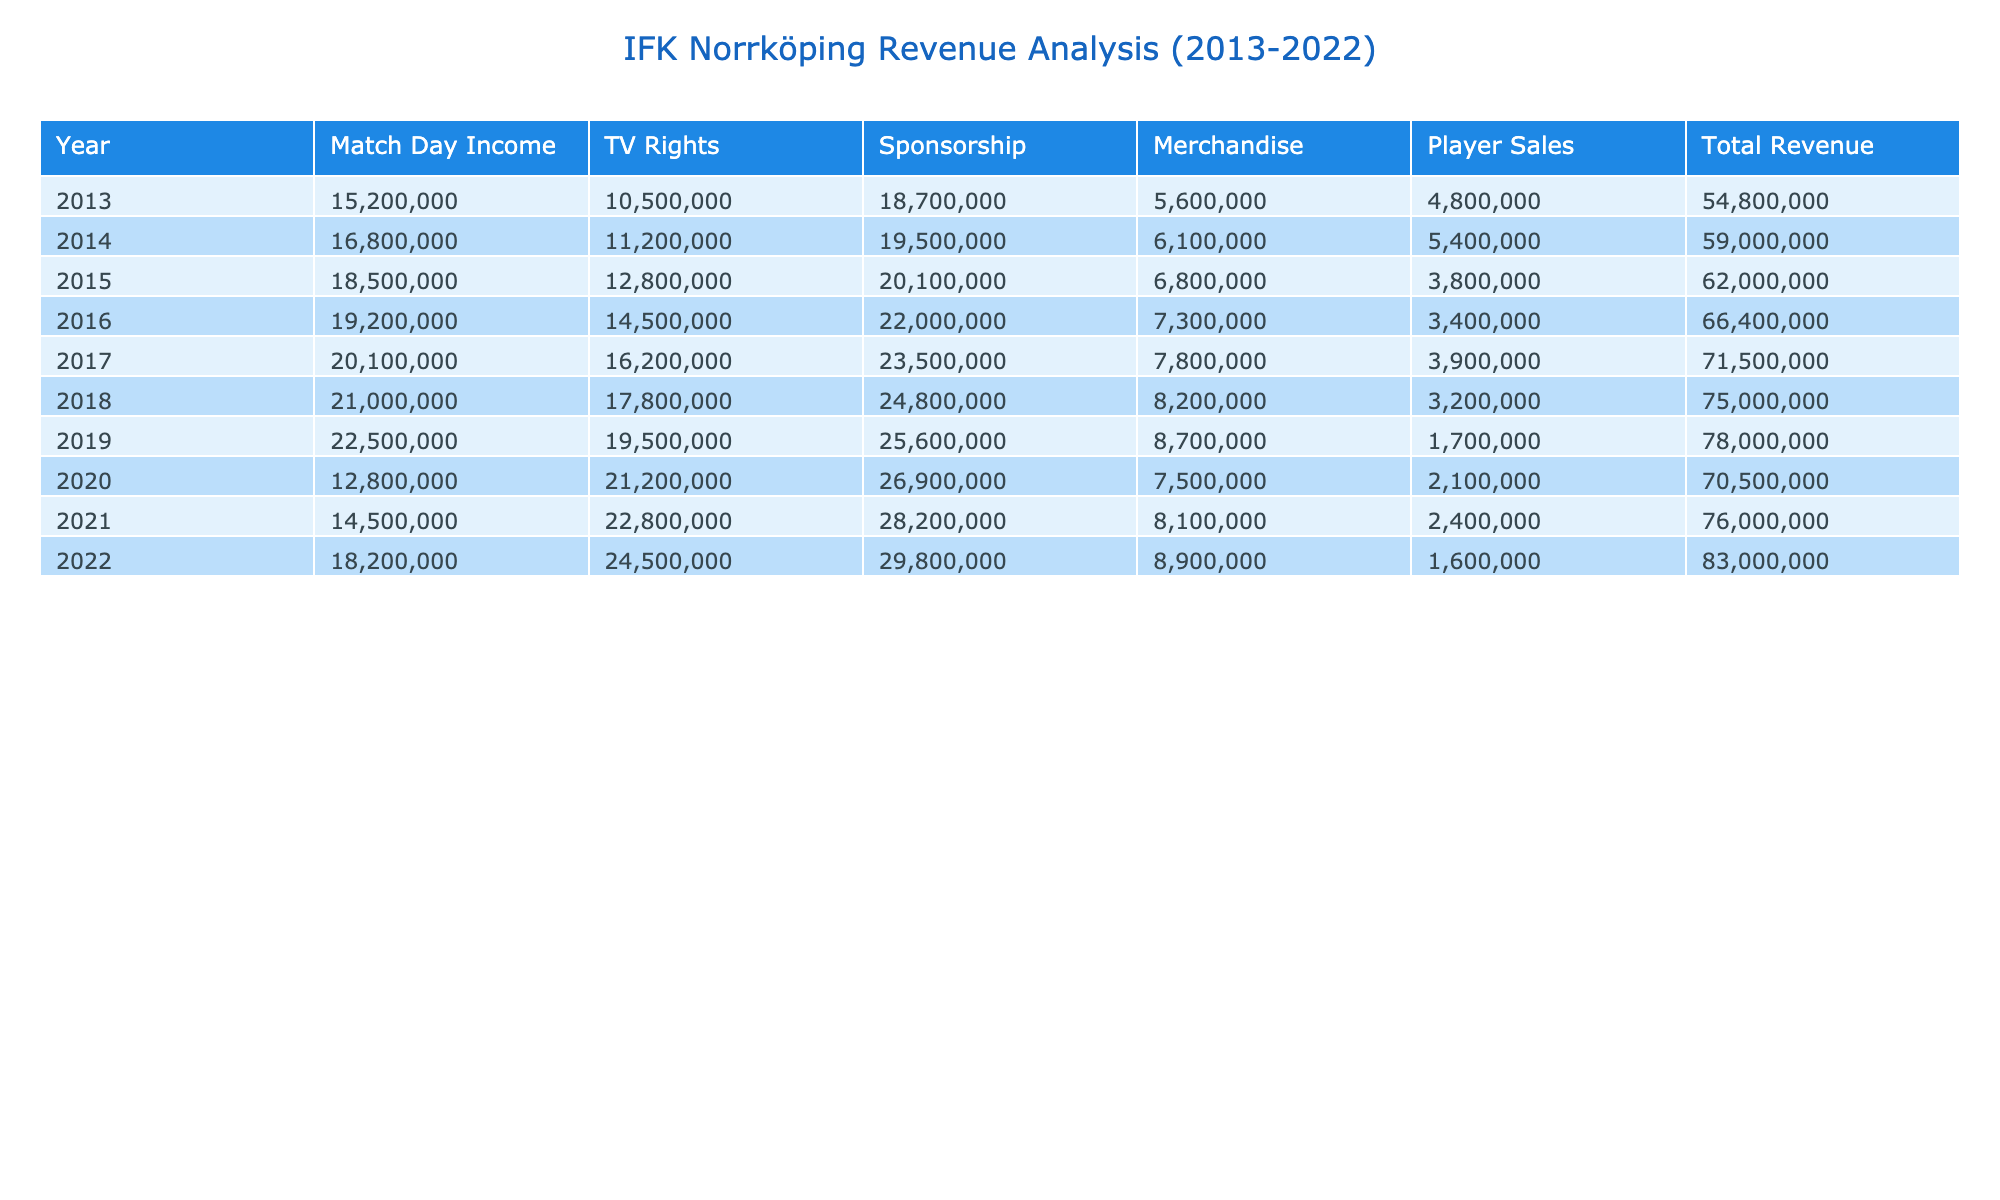What was the total revenue of IFK Norrköping in 2019? To find the total revenue for 2019, I need to sum the amounts from all revenue streams for that year: 22,500,000 (Match Day Income) + 19,500,000 (TV Rights) + 25,600,000 (Sponsorship) + 8,700,000 (Merchandise) + 1,700,000 (Player Sales) = 78,000,000 SEK.
Answer: 78,000,000 SEK Which revenue stream contributed the least percentage of total revenue in 2020? From the table, I can see that in 2020, Player Sales contributed 3% of total revenue, which is the smallest percentage compared to other revenue streams that had higher percentages (Match Day Income 18%, TV Rights 30%, Sponsorship 38%, Merchandise 11%).
Answer: Player Sales What was the average Match Day Income over the last decade? To calculate the average Match Day Income from 2013 to 2022, I sum the Match Day Income amounts across the years: 15,200,000 + 16,800,000 + 18,500,000 + 19,200,000 + 20,100,000 + 21,000,000 + 22,500,000 + 12,800,000 + 14,500,000 + 18,200,000 = 163,800,000. Then, I divide this by the number of years (10): 163,800,000 / 10 = 16,380,000 SEK.
Answer: 16,380,000 SEK Did IFK Norrköping’s sponsorship revenue increase every year from 2013 to 2022? By inspecting the sponsorship revenue for each year, I notice that it started at 18,700,000 in 2013 and increased to 29,800,000 in 2022. Every year shows a consistent increase with no decreases, making the statement true.
Answer: Yes What was the percentage of sponsorship revenue in total revenue for the year with the highest total revenue? To determine the year with the highest total revenue, I need to look at the totals for each year. The highest total revenue is in 2022, which is 82,900,000 SEK. The sponsorship amount for that year is 29,800,000 SEK. The percentage is calculated as (29,800,000 / 82,900,000) * 100 = approximately 36%.
Answer: 36% 